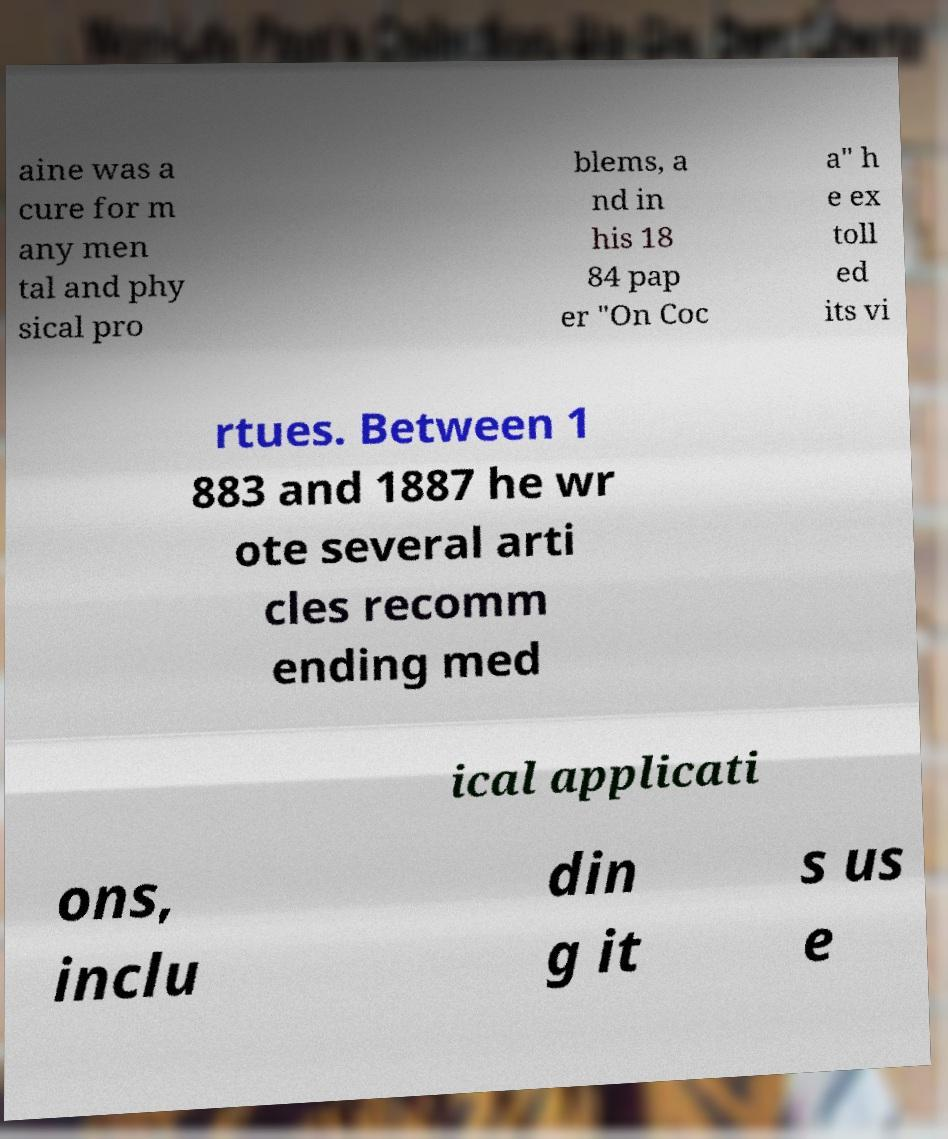Can you read and provide the text displayed in the image?This photo seems to have some interesting text. Can you extract and type it out for me? aine was a cure for m any men tal and phy sical pro blems, a nd in his 18 84 pap er "On Coc a" h e ex toll ed its vi rtues. Between 1 883 and 1887 he wr ote several arti cles recomm ending med ical applicati ons, inclu din g it s us e 